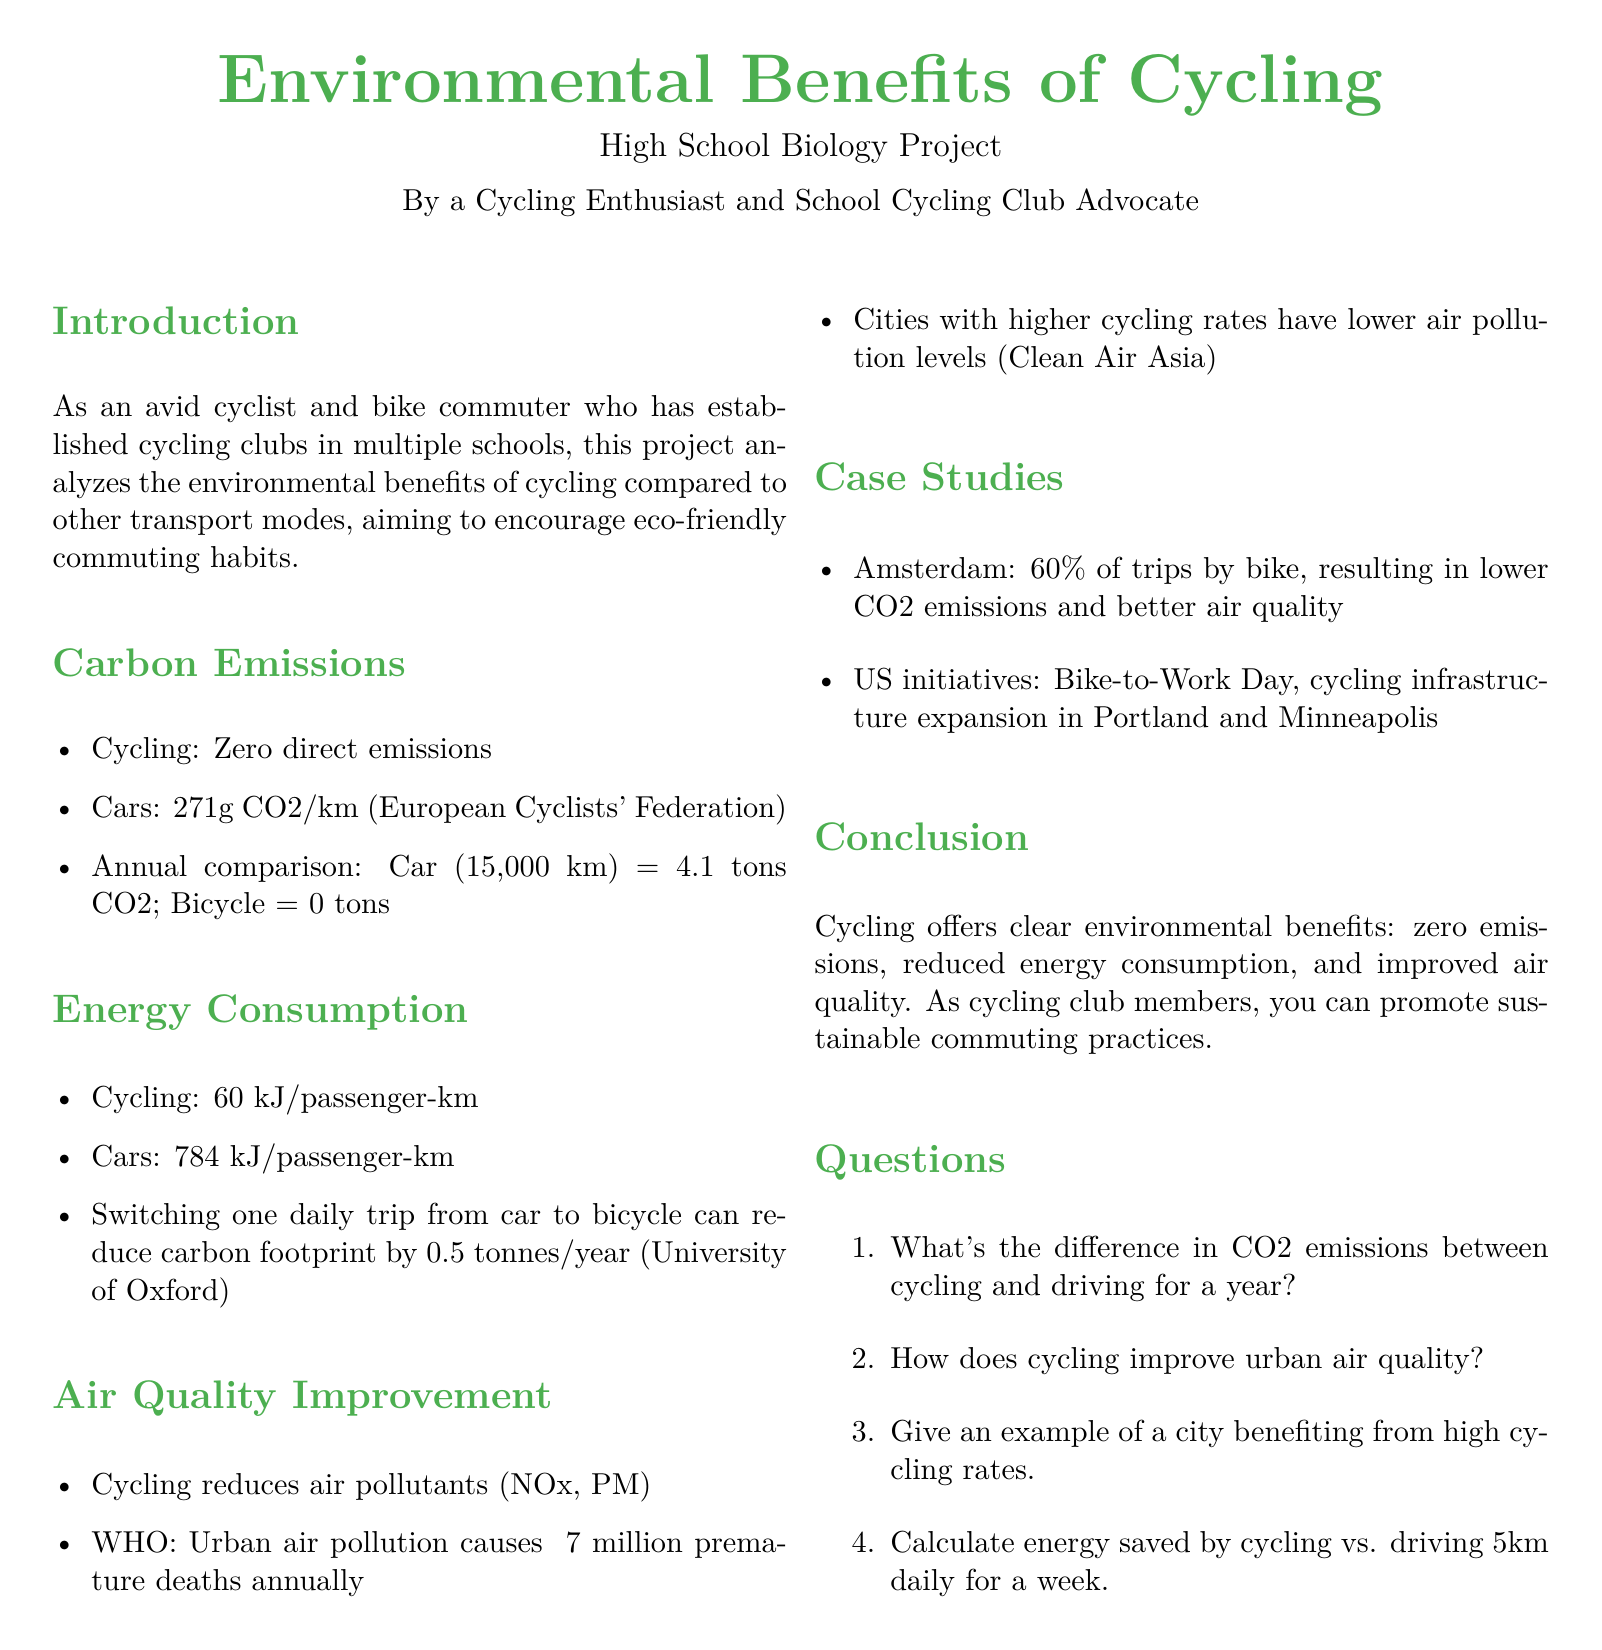What’s the CO2 emission for cars per kilometer? The document states that cars emit 271 grams of CO2 per kilometer.
Answer: 271g CO2/km What is the annual CO2 emission for a car driving 15,000 km? The document calculates the annual CO2 emission for cars at 15,000 km as 4.1 tons.
Answer: 4.1 tons CO2 How much energy does cycling consume per passenger-kilometer? The document mentions that cycling consumes 60 kJ per passenger-km.
Answer: 60 kJ/passenger-km What percentage of trips in Amsterdam are made by bike? The document indicates that 60% of trips in Amsterdam are made by bike.
Answer: 60% Which organization reports that urban air pollution causes ~7 million premature deaths annually? The document refers to the World Health Organization (WHO) regarding urban air pollution and its health impact.
Answer: WHO What is the energy consumption for cars per passenger-kilometer? The document specifies that cars consume 784 kJ per passenger-km.
Answer: 784 kJ/passenger-km How many tonnes can be reduced by switching one daily car trip to a bicycle? The document states that switching one daily trip from car to bicycle can reduce carbon footprint by 0.5 tonnes per year.
Answer: 0.5 tonnes/year Name one US city mentioned that has initiatives for cycling. The document mentions Portland as a US city with cycling initiatives.
Answer: Portland What key benefit does cycling offer according to the conclusion? The document concludes that cycling offers zero emissions as a key benefit.
Answer: Zero emissions 